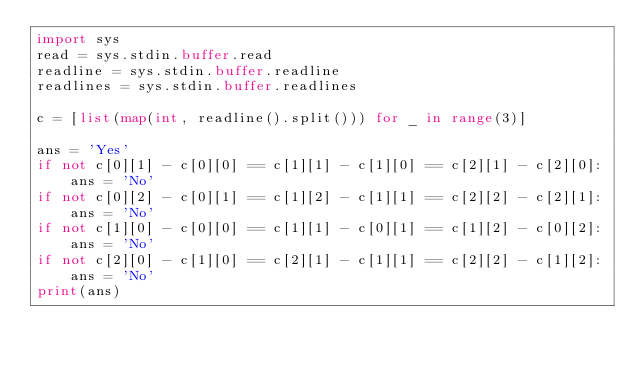<code> <loc_0><loc_0><loc_500><loc_500><_Python_>import sys
read = sys.stdin.buffer.read
readline = sys.stdin.buffer.readline
readlines = sys.stdin.buffer.readlines

c = [list(map(int, readline().split())) for _ in range(3)]

ans = 'Yes'
if not c[0][1] - c[0][0] == c[1][1] - c[1][0] == c[2][1] - c[2][0]:
    ans = 'No'
if not c[0][2] - c[0][1] == c[1][2] - c[1][1] == c[2][2] - c[2][1]:
    ans = 'No'
if not c[1][0] - c[0][0] == c[1][1] - c[0][1] == c[1][2] - c[0][2]:
    ans = 'No'
if not c[2][0] - c[1][0] == c[2][1] - c[1][1] == c[2][2] - c[1][2]:
    ans = 'No'
print(ans)
</code> 